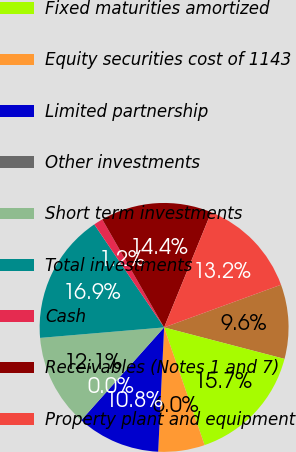Convert chart. <chart><loc_0><loc_0><loc_500><loc_500><pie_chart><fcel>December 31<fcel>Fixed maturities amortized<fcel>Equity securities cost of 1143<fcel>Limited partnership<fcel>Other investments<fcel>Short term investments<fcel>Total investments<fcel>Cash<fcel>Receivables (Notes 1 and 7)<fcel>Property plant and equipment<nl><fcel>9.64%<fcel>15.66%<fcel>6.03%<fcel>10.84%<fcel>0.01%<fcel>12.05%<fcel>16.86%<fcel>1.21%<fcel>14.45%<fcel>13.25%<nl></chart> 